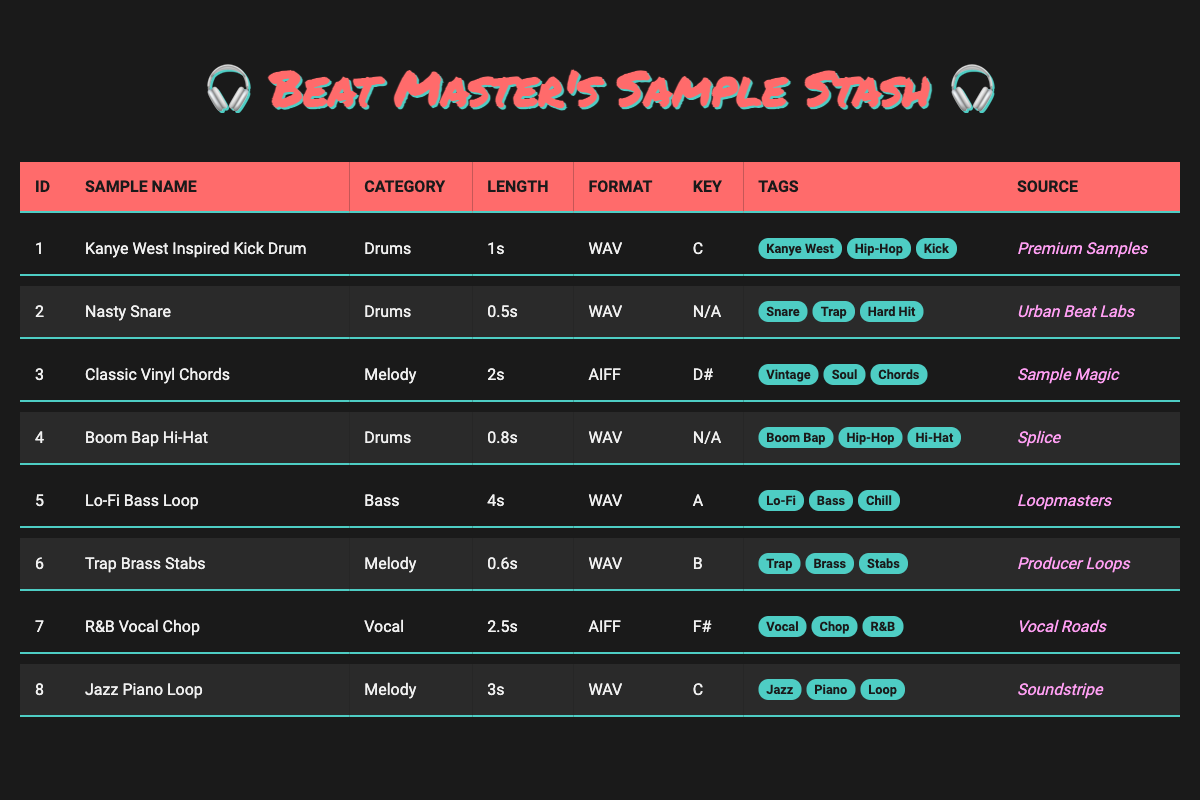What is the source of the "Kanye West Inspired Kick Drum"? By looking at the "Source" column for the sample named "Kanye West Inspired Kick Drum," we find that it is "Premium Samples."
Answer: Premium Samples How many samples are in the "Drums" category? To find the number of samples in the "Drums" category, we count the number of rows where the "Category" is "Drums." There are 4 samples: "Kanye West Inspired Kick Drum," "Nasty Snare," "Boom Bap Hi-Hat."
Answer: 4 Is the "Lo-Fi Bass Loop" longer than the "Nasty Snare"? We compare the lengths listed for each sample. "Lo-Fi Bass Loop" is 4s long while "Nasty Snare" is 0.5s long, so it is indeed longer.
Answer: Yes Which sample has the longest length, and how long is it? We check the "Length" for all samples, and "Lo-Fi Bass Loop" has the longest length of 4 seconds compared to others.
Answer: Lo-Fi Bass Loop, 4s What category does the "R&B Vocal Chop" belong to, and what is its file format? Referring to the relevant row, the "R&B Vocal Chop" is in the "Vocal" category and is in the AIFF file format.
Answer: Vocal, AIFF How many different file formats are represented in the inventory? We list the file formats: WAV and AIFF. Since WAV appears multiple times (6 times) and AIFF appears (2 times), there are only 2 different formats.
Answer: 2 Are any samples tagged with "Hip-Hop"? We check the "Tags" column for each sample and confirm that "Kanye West Inspired Kick Drum," "Boom Bap Hi-Hat" are tagged with "Hip-Hop."
Answer: Yes What is the average length of all samples in seconds? We add the lengths of all samples: 1s + 0.5s + 2s + 0.8s + 4s + 0.6s + 2.5s + 3s = 14.4 seconds. There are 8 samples, so the average length is 14.4s / 8 = 1.8 seconds.
Answer: 1.8 seconds 